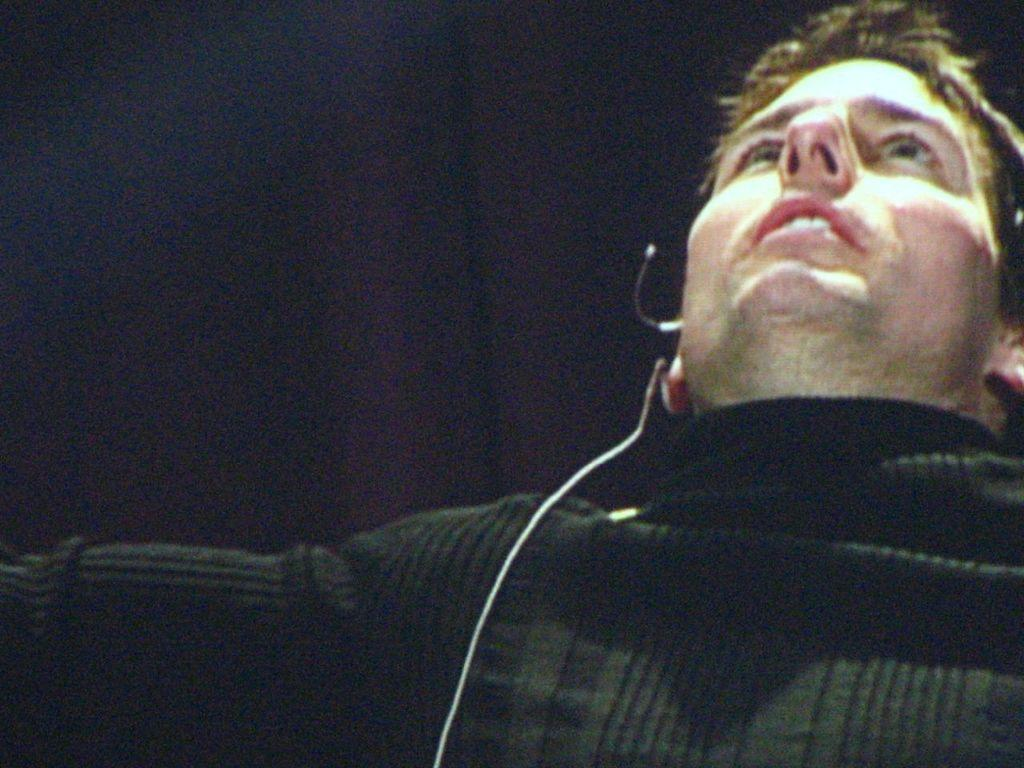Who is present in the image? There is a man in the image. What is the man wearing in the image? The man is wearing a microphone. What type of ray can be seen swimming near the dock in the image? There is no ray or dock present in the image; it only features a man wearing a microphone. 